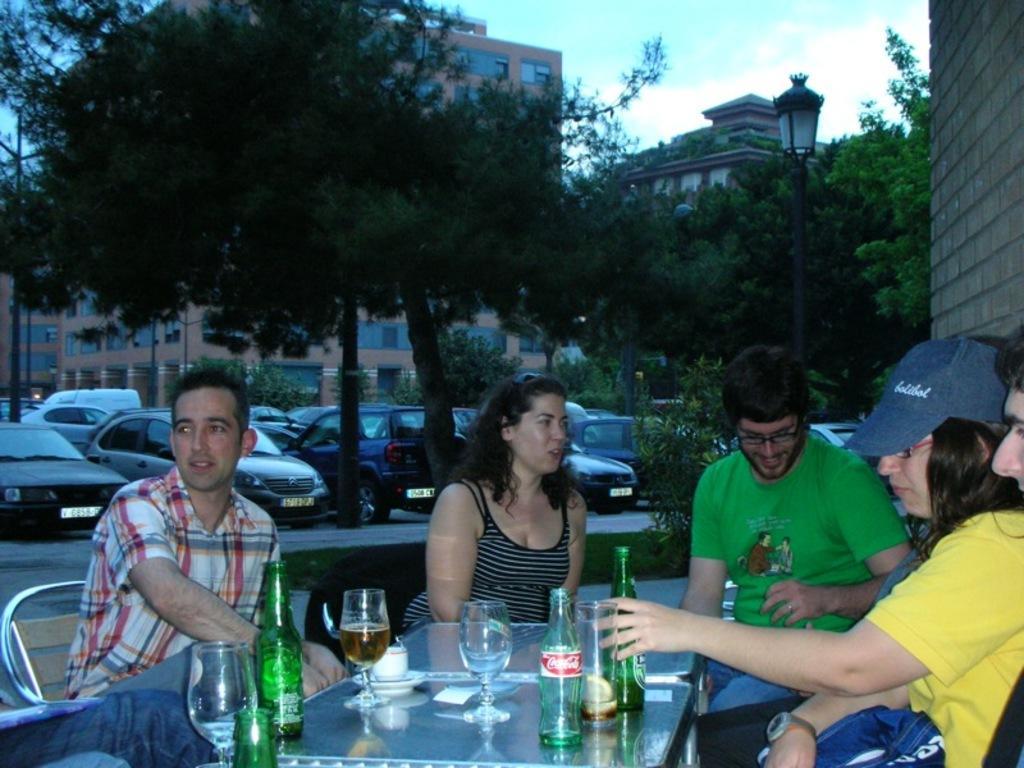Could you give a brief overview of what you see in this image? people are sitting on the chair around the table. on the table there are glass bottles and glasses. behind them there are cars, trees. at the back there are buildings. 